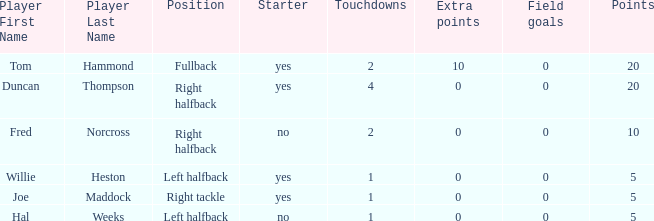Would you mind parsing the complete table? {'header': ['Player First Name', 'Player Last Name', 'Position', 'Starter', 'Touchdowns', 'Extra points', 'Field goals', 'Points'], 'rows': [['Tom', 'Hammond', 'Fullback', 'yes', '2', '10', '0', '20'], ['Duncan', 'Thompson', 'Right halfback', 'yes', '4', '0', '0', '20'], ['Fred', 'Norcross', 'Right halfback', 'no', '2', '0', '0', '10'], ['Willie', 'Heston', 'Left halfback', 'yes', '1', '0', '0', '5'], ['Joe', 'Maddock', 'Right tackle', 'yes', '1', '0', '0', '5'], ['Hal', 'Weeks', 'Left halfback', 'no', '1', '0', '0', '5']]} What is the highest field goals when there were more than 1 touchdown and 0 extra points? 0.0. 